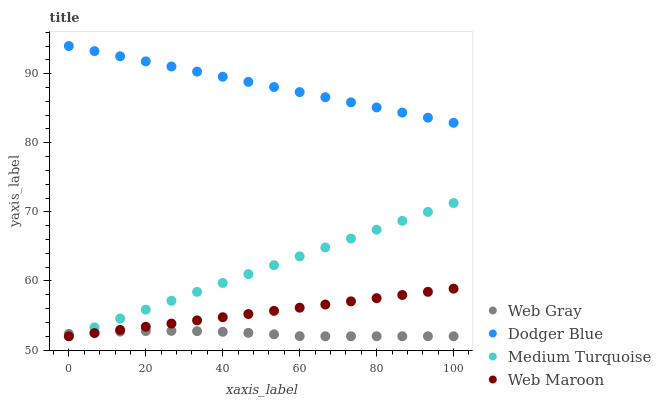Does Web Gray have the minimum area under the curve?
Answer yes or no. Yes. Does Dodger Blue have the maximum area under the curve?
Answer yes or no. Yes. Does Dodger Blue have the minimum area under the curve?
Answer yes or no. No. Does Web Gray have the maximum area under the curve?
Answer yes or no. No. Is Web Maroon the smoothest?
Answer yes or no. Yes. Is Web Gray the roughest?
Answer yes or no. Yes. Is Dodger Blue the smoothest?
Answer yes or no. No. Is Dodger Blue the roughest?
Answer yes or no. No. Does Web Maroon have the lowest value?
Answer yes or no. Yes. Does Dodger Blue have the lowest value?
Answer yes or no. No. Does Dodger Blue have the highest value?
Answer yes or no. Yes. Does Web Gray have the highest value?
Answer yes or no. No. Is Web Maroon less than Dodger Blue?
Answer yes or no. Yes. Is Dodger Blue greater than Medium Turquoise?
Answer yes or no. Yes. Does Web Maroon intersect Medium Turquoise?
Answer yes or no. Yes. Is Web Maroon less than Medium Turquoise?
Answer yes or no. No. Is Web Maroon greater than Medium Turquoise?
Answer yes or no. No. Does Web Maroon intersect Dodger Blue?
Answer yes or no. No. 